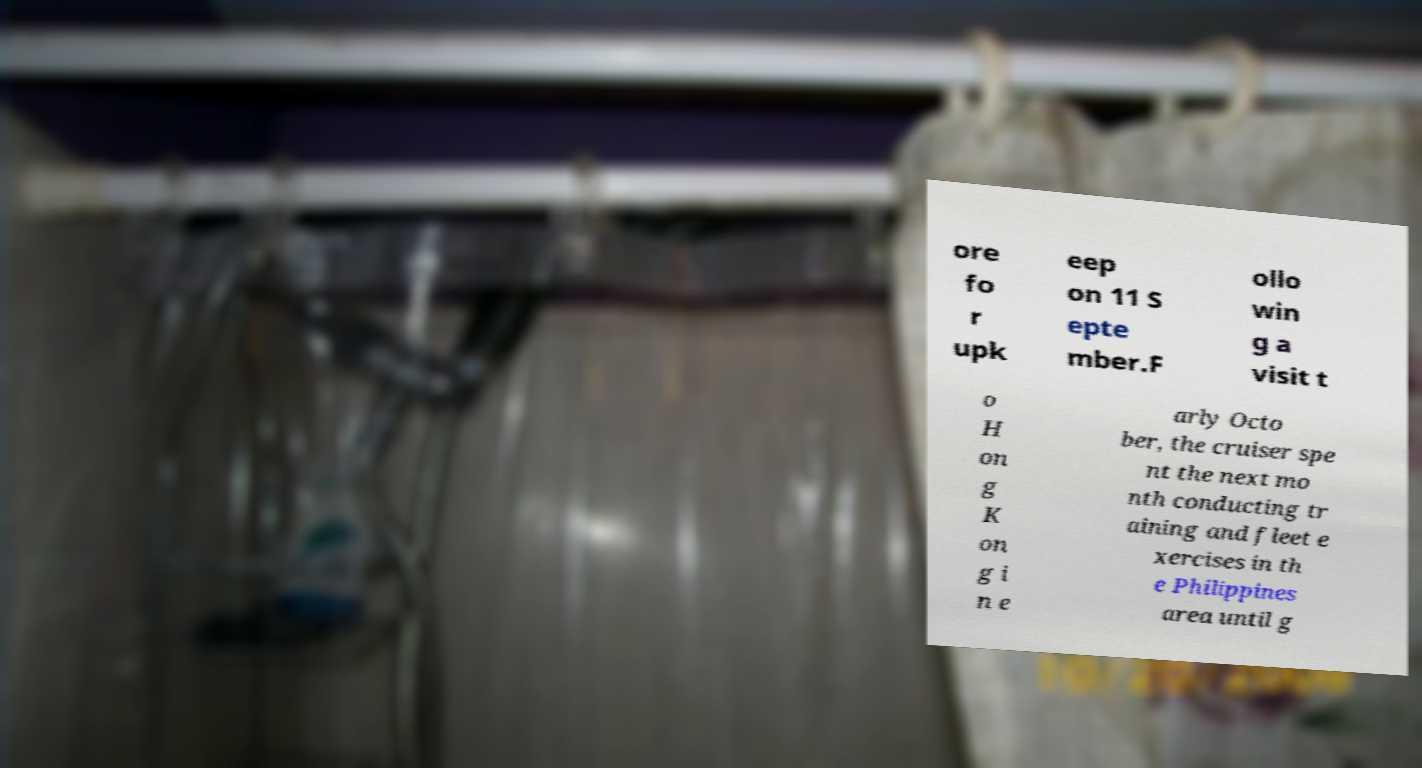Can you accurately transcribe the text from the provided image for me? ore fo r upk eep on 11 S epte mber.F ollo win g a visit t o H on g K on g i n e arly Octo ber, the cruiser spe nt the next mo nth conducting tr aining and fleet e xercises in th e Philippines area until g 